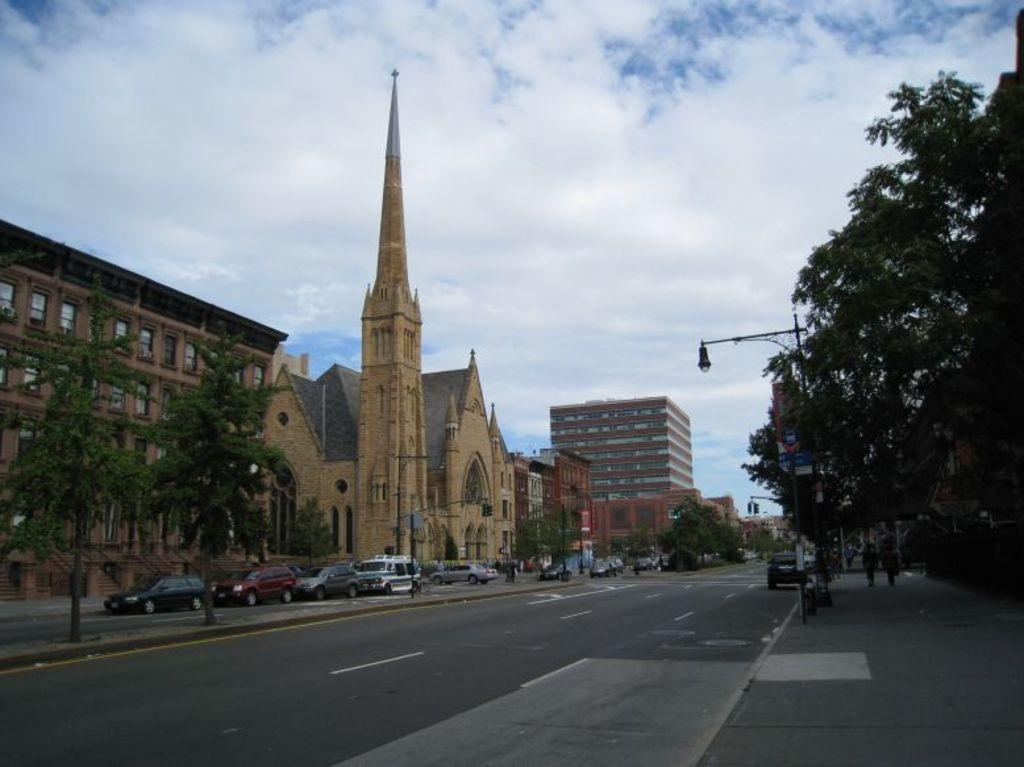What is the main feature of the image? There is a road in the image. What can be seen on either side of the road? The road is situated between trees. What else can be seen in the image besides the road and trees? There are cars beside buildings in the image. What is located in the middle of the image? There is a street pole in the middle of the image. What is visible at the top of the image? The sky is visible at the top of the image. What type of organization is responsible for the chain of events depicted in the image? There is no chain of events or organization present in the image; it features a road, trees, buildings, a street pole, and the sky. 